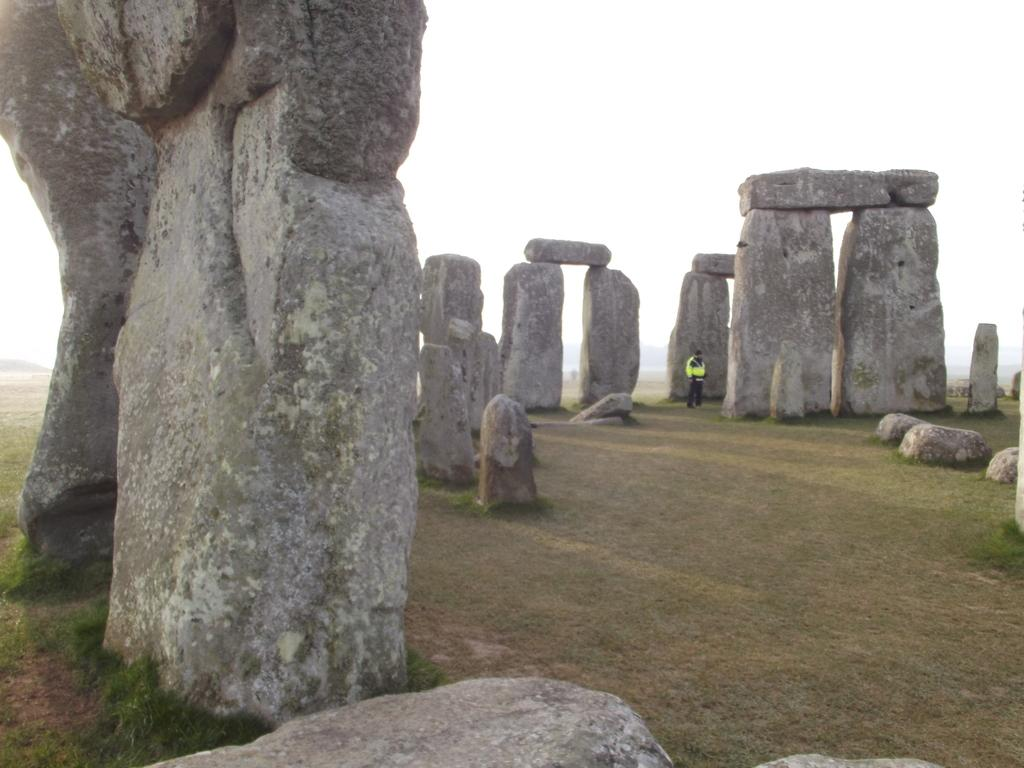What type of objects are present in the image? There are stones in the image. How are the stones arranged or positioned? Some stones are placed on other stones. Is there any person visible in the image? Yes, there is a man standing on the ground at the stone in the background. What can be seen in the background of the image? The sky is visible in the background. What type of music is the band playing in the background of the image? There is no band present in the image, so it is not possible to determine what type of music they might be playing. 